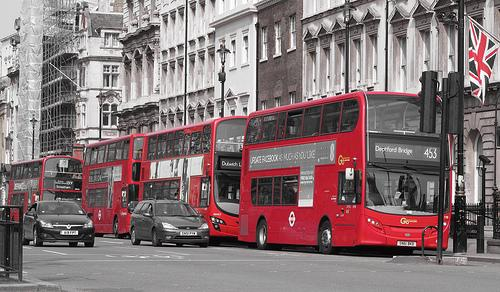In terms of buses, what is the most notable feature in the image? Also, how many street signals are there? There are four double decker buses which are the most notable feature, and there are two street signals on a pole. Explain what the flag in the image looks like and where it's located. The flag is a red, white, and blue British flag located on a tall black flag pole. What do the housing for street lights and the surrounding objects look like? The housing for street lights is surrounded by a black traffic light and a lamp post on the sidewalk. Identify the camera and lamp post in the image, and their relative positions. There is a traffic camera next to a light pole, and a black light post near a metal street light. What are some details about the windows on the bus, and how many are mentioned in the image? There are six bus windows mentioned in the image, and they are of different sizes and positions. What type of construction is going on in the image and what do the railings look like? There is construction on the building, and the railings are black. What are the colors and positions of the vehicles below the red buses?  A grey mini van is next to the bus, and a black car is on the street. Could you please mention the two types of vehicles parked on the street? There are two cars, a mini van and a dark colored sedan, parked on the street. Find different objects near the street corner and describe them. There is a trash can on the street corner, a black metal fence, and white painted lines on the street. What color is the double decker bus and what is its front number? The double decker bus is red and its front number is 453. 